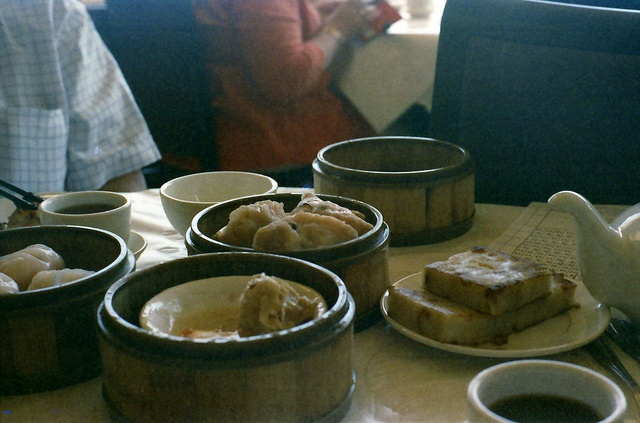Describe the objects in this image and their specific colors. I can see chair in gray, black, blue, and darkblue tones, bowl in gray, black, darkgreen, and darkgray tones, people in gray and black tones, people in gray and darkgray tones, and bowl in gray, black, darkgreen, and darkgray tones in this image. 